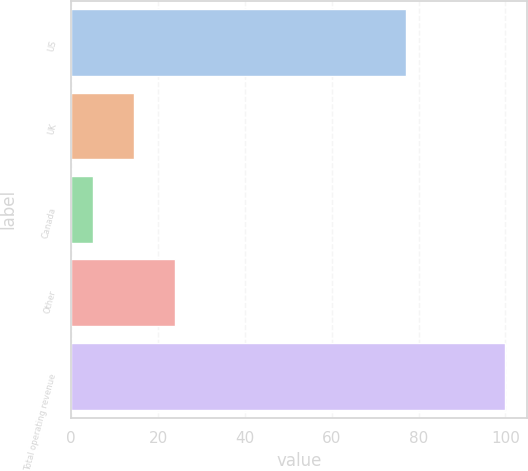<chart> <loc_0><loc_0><loc_500><loc_500><bar_chart><fcel>US<fcel>UK<fcel>Canada<fcel>Other<fcel>Total operating revenue<nl><fcel>77<fcel>14.5<fcel>5<fcel>24<fcel>100<nl></chart> 